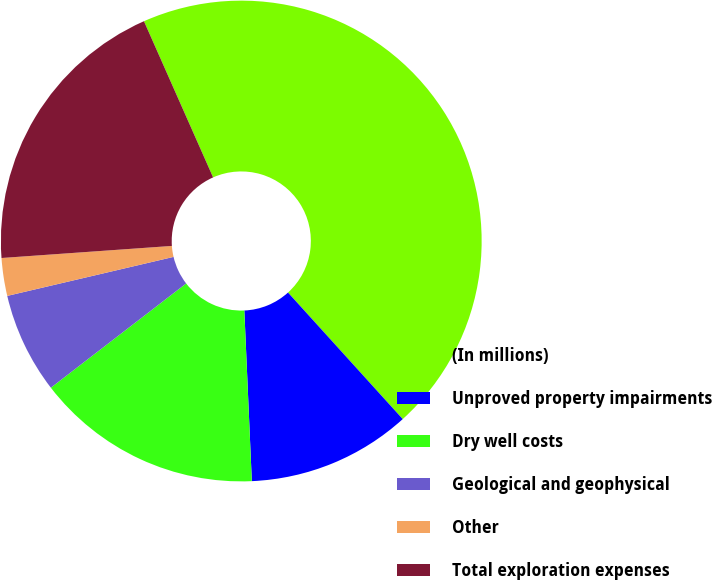Convert chart to OTSL. <chart><loc_0><loc_0><loc_500><loc_500><pie_chart><fcel>(In millions)<fcel>Unproved property impairments<fcel>Dry well costs<fcel>Geological and geophysical<fcel>Other<fcel>Total exploration expenses<nl><fcel>44.91%<fcel>11.02%<fcel>15.25%<fcel>6.78%<fcel>2.54%<fcel>19.49%<nl></chart> 